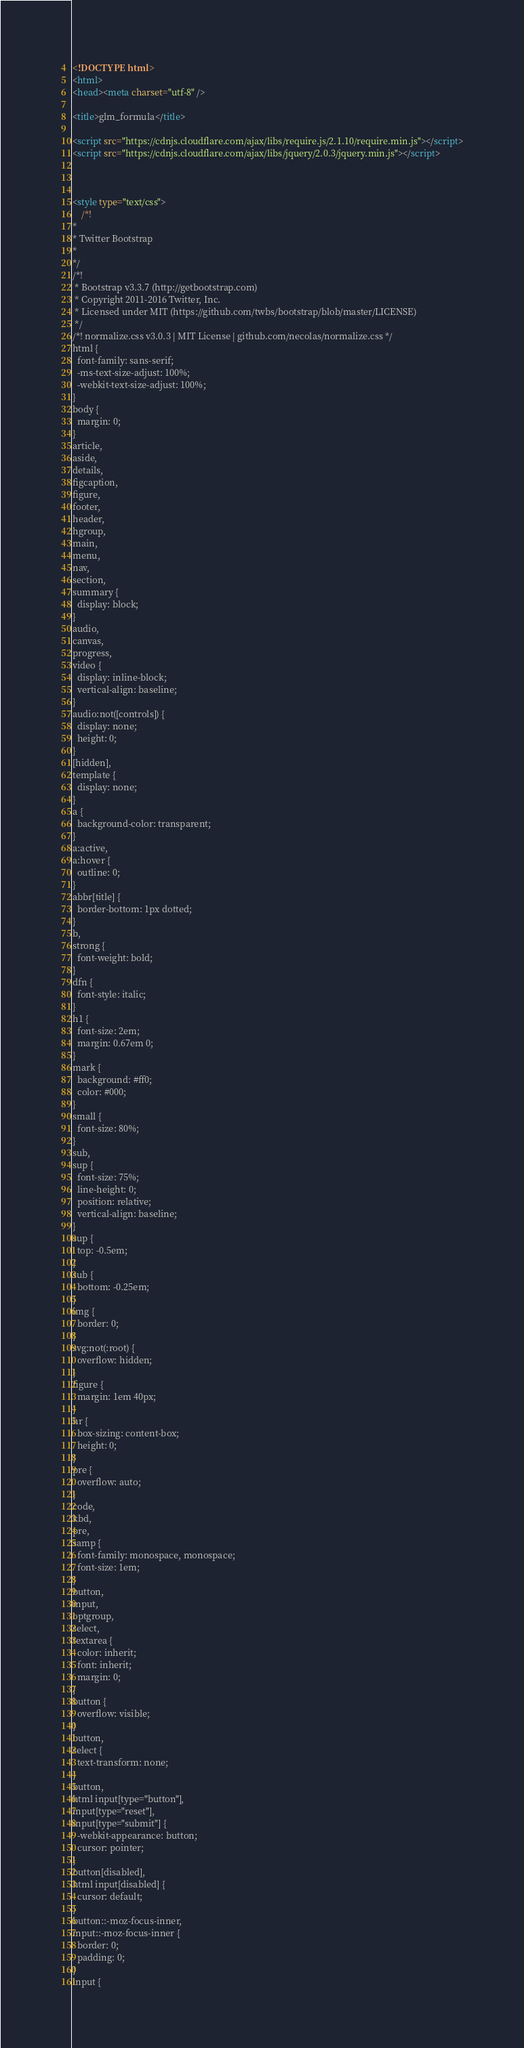<code> <loc_0><loc_0><loc_500><loc_500><_HTML_><!DOCTYPE html>
<html>
<head><meta charset="utf-8" />

<title>glm_formula</title>

<script src="https://cdnjs.cloudflare.com/ajax/libs/require.js/2.1.10/require.min.js"></script>
<script src="https://cdnjs.cloudflare.com/ajax/libs/jquery/2.0.3/jquery.min.js"></script>



<style type="text/css">
    /*!
*
* Twitter Bootstrap
*
*/
/*!
 * Bootstrap v3.3.7 (http://getbootstrap.com)
 * Copyright 2011-2016 Twitter, Inc.
 * Licensed under MIT (https://github.com/twbs/bootstrap/blob/master/LICENSE)
 */
/*! normalize.css v3.0.3 | MIT License | github.com/necolas/normalize.css */
html {
  font-family: sans-serif;
  -ms-text-size-adjust: 100%;
  -webkit-text-size-adjust: 100%;
}
body {
  margin: 0;
}
article,
aside,
details,
figcaption,
figure,
footer,
header,
hgroup,
main,
menu,
nav,
section,
summary {
  display: block;
}
audio,
canvas,
progress,
video {
  display: inline-block;
  vertical-align: baseline;
}
audio:not([controls]) {
  display: none;
  height: 0;
}
[hidden],
template {
  display: none;
}
a {
  background-color: transparent;
}
a:active,
a:hover {
  outline: 0;
}
abbr[title] {
  border-bottom: 1px dotted;
}
b,
strong {
  font-weight: bold;
}
dfn {
  font-style: italic;
}
h1 {
  font-size: 2em;
  margin: 0.67em 0;
}
mark {
  background: #ff0;
  color: #000;
}
small {
  font-size: 80%;
}
sub,
sup {
  font-size: 75%;
  line-height: 0;
  position: relative;
  vertical-align: baseline;
}
sup {
  top: -0.5em;
}
sub {
  bottom: -0.25em;
}
img {
  border: 0;
}
svg:not(:root) {
  overflow: hidden;
}
figure {
  margin: 1em 40px;
}
hr {
  box-sizing: content-box;
  height: 0;
}
pre {
  overflow: auto;
}
code,
kbd,
pre,
samp {
  font-family: monospace, monospace;
  font-size: 1em;
}
button,
input,
optgroup,
select,
textarea {
  color: inherit;
  font: inherit;
  margin: 0;
}
button {
  overflow: visible;
}
button,
select {
  text-transform: none;
}
button,
html input[type="button"],
input[type="reset"],
input[type="submit"] {
  -webkit-appearance: button;
  cursor: pointer;
}
button[disabled],
html input[disabled] {
  cursor: default;
}
button::-moz-focus-inner,
input::-moz-focus-inner {
  border: 0;
  padding: 0;
}
input {</code> 